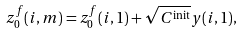<formula> <loc_0><loc_0><loc_500><loc_500>z _ { 0 } ^ { f } ( i , m ) = z _ { 0 } ^ { f } ( i , 1 ) + \sqrt { C ^ { \text {init} } } y ( i , 1 ) ,</formula> 